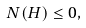Convert formula to latex. <formula><loc_0><loc_0><loc_500><loc_500>N ( H ) \leq 0 ,</formula> 